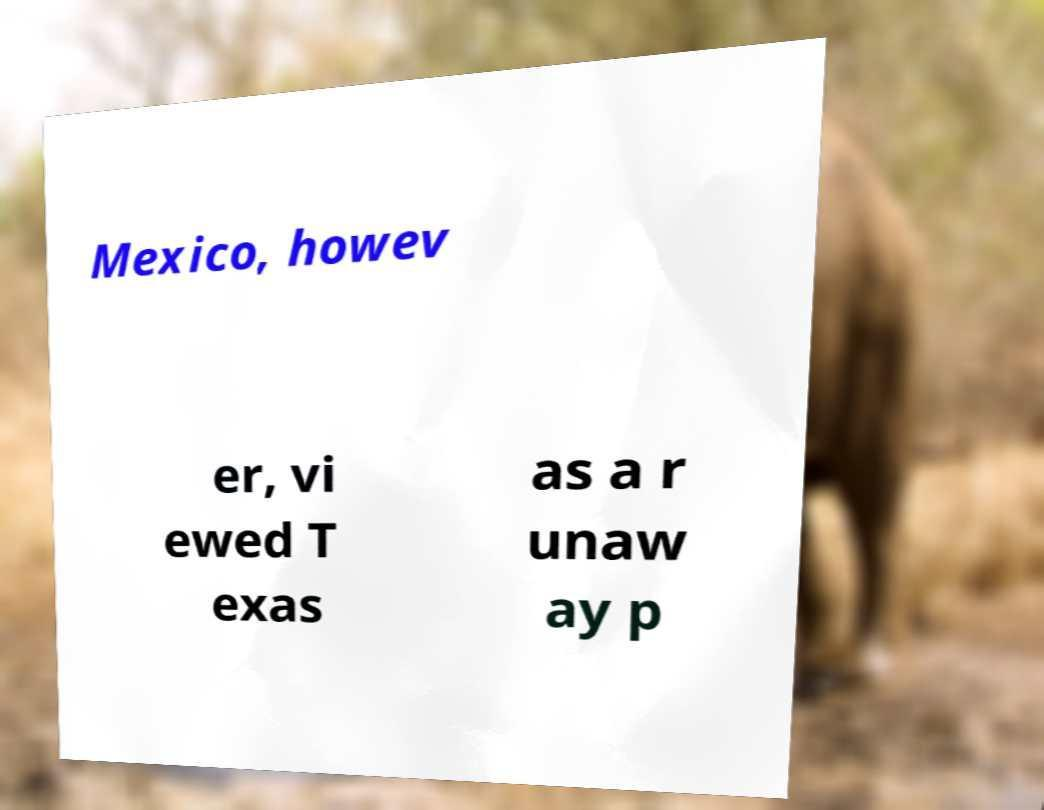Could you assist in decoding the text presented in this image and type it out clearly? Mexico, howev er, vi ewed T exas as a r unaw ay p 